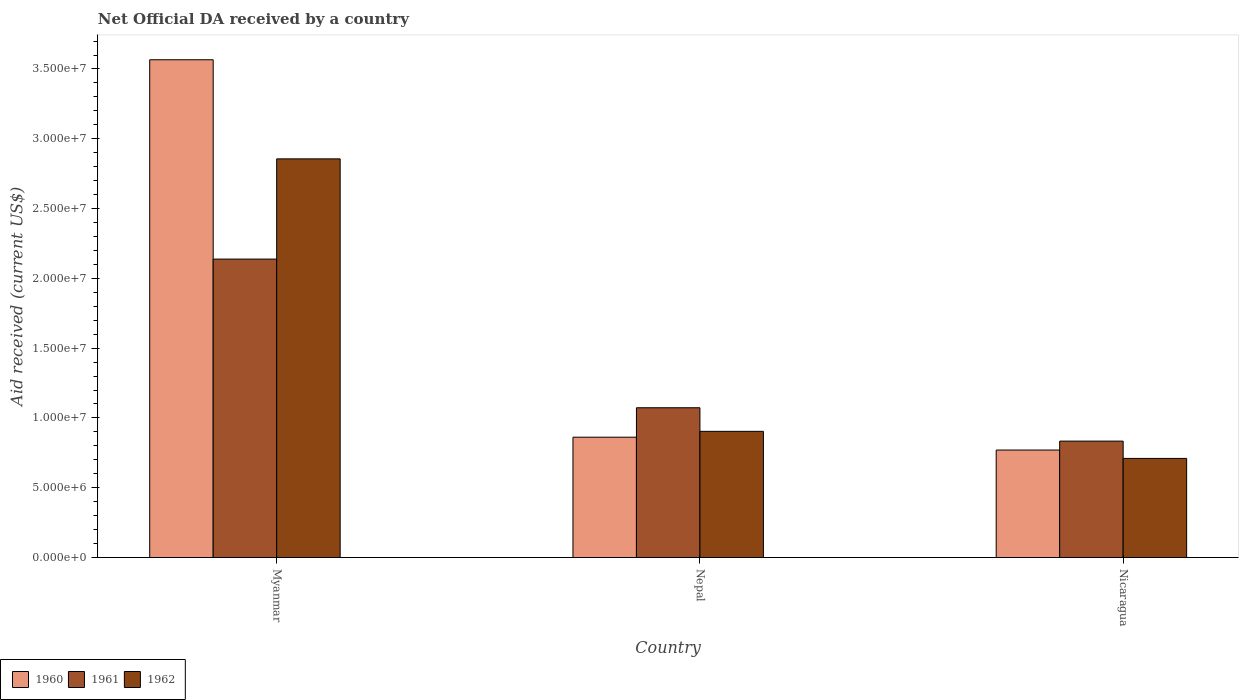How many different coloured bars are there?
Offer a terse response. 3. Are the number of bars on each tick of the X-axis equal?
Offer a very short reply. Yes. How many bars are there on the 2nd tick from the left?
Your answer should be compact. 3. How many bars are there on the 1st tick from the right?
Your answer should be compact. 3. What is the label of the 3rd group of bars from the left?
Your answer should be compact. Nicaragua. What is the net official development assistance aid received in 1962 in Nicaragua?
Offer a terse response. 7.10e+06. Across all countries, what is the maximum net official development assistance aid received in 1962?
Provide a succinct answer. 2.86e+07. Across all countries, what is the minimum net official development assistance aid received in 1962?
Provide a short and direct response. 7.10e+06. In which country was the net official development assistance aid received in 1960 maximum?
Provide a short and direct response. Myanmar. In which country was the net official development assistance aid received in 1960 minimum?
Your answer should be compact. Nicaragua. What is the total net official development assistance aid received in 1960 in the graph?
Offer a very short reply. 5.20e+07. What is the difference between the net official development assistance aid received in 1960 in Myanmar and that in Nepal?
Provide a succinct answer. 2.70e+07. What is the difference between the net official development assistance aid received in 1960 in Myanmar and the net official development assistance aid received in 1961 in Nicaragua?
Offer a terse response. 2.73e+07. What is the average net official development assistance aid received in 1962 per country?
Your response must be concise. 1.49e+07. What is the difference between the net official development assistance aid received of/in 1960 and net official development assistance aid received of/in 1961 in Nepal?
Ensure brevity in your answer.  -2.11e+06. What is the ratio of the net official development assistance aid received in 1961 in Nepal to that in Nicaragua?
Your response must be concise. 1.29. Is the difference between the net official development assistance aid received in 1960 in Myanmar and Nicaragua greater than the difference between the net official development assistance aid received in 1961 in Myanmar and Nicaragua?
Your response must be concise. Yes. What is the difference between the highest and the second highest net official development assistance aid received in 1961?
Your answer should be very brief. 1.06e+07. What is the difference between the highest and the lowest net official development assistance aid received in 1962?
Offer a very short reply. 2.15e+07. In how many countries, is the net official development assistance aid received in 1961 greater than the average net official development assistance aid received in 1961 taken over all countries?
Make the answer very short. 1. How many bars are there?
Offer a very short reply. 9. How many countries are there in the graph?
Provide a succinct answer. 3. What is the difference between two consecutive major ticks on the Y-axis?
Keep it short and to the point. 5.00e+06. Are the values on the major ticks of Y-axis written in scientific E-notation?
Your answer should be compact. Yes. Does the graph contain any zero values?
Keep it short and to the point. No. Does the graph contain grids?
Make the answer very short. No. How many legend labels are there?
Make the answer very short. 3. What is the title of the graph?
Make the answer very short. Net Official DA received by a country. Does "1993" appear as one of the legend labels in the graph?
Your response must be concise. No. What is the label or title of the Y-axis?
Make the answer very short. Aid received (current US$). What is the Aid received (current US$) in 1960 in Myanmar?
Offer a very short reply. 3.57e+07. What is the Aid received (current US$) in 1961 in Myanmar?
Keep it short and to the point. 2.14e+07. What is the Aid received (current US$) of 1962 in Myanmar?
Your answer should be very brief. 2.86e+07. What is the Aid received (current US$) in 1960 in Nepal?
Make the answer very short. 8.62e+06. What is the Aid received (current US$) of 1961 in Nepal?
Offer a very short reply. 1.07e+07. What is the Aid received (current US$) of 1962 in Nepal?
Offer a terse response. 9.04e+06. What is the Aid received (current US$) of 1960 in Nicaragua?
Your answer should be compact. 7.70e+06. What is the Aid received (current US$) of 1961 in Nicaragua?
Make the answer very short. 8.34e+06. What is the Aid received (current US$) in 1962 in Nicaragua?
Offer a terse response. 7.10e+06. Across all countries, what is the maximum Aid received (current US$) in 1960?
Offer a terse response. 3.57e+07. Across all countries, what is the maximum Aid received (current US$) of 1961?
Your answer should be very brief. 2.14e+07. Across all countries, what is the maximum Aid received (current US$) of 1962?
Your answer should be compact. 2.86e+07. Across all countries, what is the minimum Aid received (current US$) of 1960?
Ensure brevity in your answer.  7.70e+06. Across all countries, what is the minimum Aid received (current US$) in 1961?
Make the answer very short. 8.34e+06. Across all countries, what is the minimum Aid received (current US$) in 1962?
Your response must be concise. 7.10e+06. What is the total Aid received (current US$) of 1960 in the graph?
Your response must be concise. 5.20e+07. What is the total Aid received (current US$) of 1961 in the graph?
Offer a very short reply. 4.04e+07. What is the total Aid received (current US$) in 1962 in the graph?
Offer a very short reply. 4.47e+07. What is the difference between the Aid received (current US$) in 1960 in Myanmar and that in Nepal?
Ensure brevity in your answer.  2.70e+07. What is the difference between the Aid received (current US$) in 1961 in Myanmar and that in Nepal?
Keep it short and to the point. 1.06e+07. What is the difference between the Aid received (current US$) in 1962 in Myanmar and that in Nepal?
Offer a terse response. 1.95e+07. What is the difference between the Aid received (current US$) in 1960 in Myanmar and that in Nicaragua?
Ensure brevity in your answer.  2.80e+07. What is the difference between the Aid received (current US$) in 1961 in Myanmar and that in Nicaragua?
Your answer should be compact. 1.30e+07. What is the difference between the Aid received (current US$) of 1962 in Myanmar and that in Nicaragua?
Give a very brief answer. 2.15e+07. What is the difference between the Aid received (current US$) in 1960 in Nepal and that in Nicaragua?
Your response must be concise. 9.20e+05. What is the difference between the Aid received (current US$) of 1961 in Nepal and that in Nicaragua?
Offer a terse response. 2.39e+06. What is the difference between the Aid received (current US$) of 1962 in Nepal and that in Nicaragua?
Your response must be concise. 1.94e+06. What is the difference between the Aid received (current US$) in 1960 in Myanmar and the Aid received (current US$) in 1961 in Nepal?
Your answer should be compact. 2.49e+07. What is the difference between the Aid received (current US$) in 1960 in Myanmar and the Aid received (current US$) in 1962 in Nepal?
Provide a short and direct response. 2.66e+07. What is the difference between the Aid received (current US$) of 1961 in Myanmar and the Aid received (current US$) of 1962 in Nepal?
Your answer should be compact. 1.23e+07. What is the difference between the Aid received (current US$) of 1960 in Myanmar and the Aid received (current US$) of 1961 in Nicaragua?
Provide a succinct answer. 2.73e+07. What is the difference between the Aid received (current US$) of 1960 in Myanmar and the Aid received (current US$) of 1962 in Nicaragua?
Your answer should be compact. 2.86e+07. What is the difference between the Aid received (current US$) of 1961 in Myanmar and the Aid received (current US$) of 1962 in Nicaragua?
Your response must be concise. 1.43e+07. What is the difference between the Aid received (current US$) of 1960 in Nepal and the Aid received (current US$) of 1962 in Nicaragua?
Provide a short and direct response. 1.52e+06. What is the difference between the Aid received (current US$) in 1961 in Nepal and the Aid received (current US$) in 1962 in Nicaragua?
Keep it short and to the point. 3.63e+06. What is the average Aid received (current US$) of 1960 per country?
Keep it short and to the point. 1.73e+07. What is the average Aid received (current US$) in 1961 per country?
Your response must be concise. 1.35e+07. What is the average Aid received (current US$) of 1962 per country?
Your answer should be very brief. 1.49e+07. What is the difference between the Aid received (current US$) of 1960 and Aid received (current US$) of 1961 in Myanmar?
Give a very brief answer. 1.43e+07. What is the difference between the Aid received (current US$) in 1960 and Aid received (current US$) in 1962 in Myanmar?
Make the answer very short. 7.10e+06. What is the difference between the Aid received (current US$) of 1961 and Aid received (current US$) of 1962 in Myanmar?
Provide a succinct answer. -7.18e+06. What is the difference between the Aid received (current US$) in 1960 and Aid received (current US$) in 1961 in Nepal?
Keep it short and to the point. -2.11e+06. What is the difference between the Aid received (current US$) of 1960 and Aid received (current US$) of 1962 in Nepal?
Make the answer very short. -4.20e+05. What is the difference between the Aid received (current US$) in 1961 and Aid received (current US$) in 1962 in Nepal?
Make the answer very short. 1.69e+06. What is the difference between the Aid received (current US$) of 1960 and Aid received (current US$) of 1961 in Nicaragua?
Provide a succinct answer. -6.40e+05. What is the difference between the Aid received (current US$) of 1960 and Aid received (current US$) of 1962 in Nicaragua?
Make the answer very short. 6.00e+05. What is the difference between the Aid received (current US$) in 1961 and Aid received (current US$) in 1962 in Nicaragua?
Keep it short and to the point. 1.24e+06. What is the ratio of the Aid received (current US$) of 1960 in Myanmar to that in Nepal?
Offer a very short reply. 4.14. What is the ratio of the Aid received (current US$) of 1961 in Myanmar to that in Nepal?
Provide a succinct answer. 1.99. What is the ratio of the Aid received (current US$) of 1962 in Myanmar to that in Nepal?
Ensure brevity in your answer.  3.16. What is the ratio of the Aid received (current US$) in 1960 in Myanmar to that in Nicaragua?
Keep it short and to the point. 4.63. What is the ratio of the Aid received (current US$) in 1961 in Myanmar to that in Nicaragua?
Make the answer very short. 2.56. What is the ratio of the Aid received (current US$) of 1962 in Myanmar to that in Nicaragua?
Ensure brevity in your answer.  4.02. What is the ratio of the Aid received (current US$) in 1960 in Nepal to that in Nicaragua?
Make the answer very short. 1.12. What is the ratio of the Aid received (current US$) of 1961 in Nepal to that in Nicaragua?
Your answer should be very brief. 1.29. What is the ratio of the Aid received (current US$) in 1962 in Nepal to that in Nicaragua?
Offer a very short reply. 1.27. What is the difference between the highest and the second highest Aid received (current US$) of 1960?
Your response must be concise. 2.70e+07. What is the difference between the highest and the second highest Aid received (current US$) of 1961?
Keep it short and to the point. 1.06e+07. What is the difference between the highest and the second highest Aid received (current US$) in 1962?
Your answer should be compact. 1.95e+07. What is the difference between the highest and the lowest Aid received (current US$) in 1960?
Offer a very short reply. 2.80e+07. What is the difference between the highest and the lowest Aid received (current US$) in 1961?
Ensure brevity in your answer.  1.30e+07. What is the difference between the highest and the lowest Aid received (current US$) in 1962?
Keep it short and to the point. 2.15e+07. 